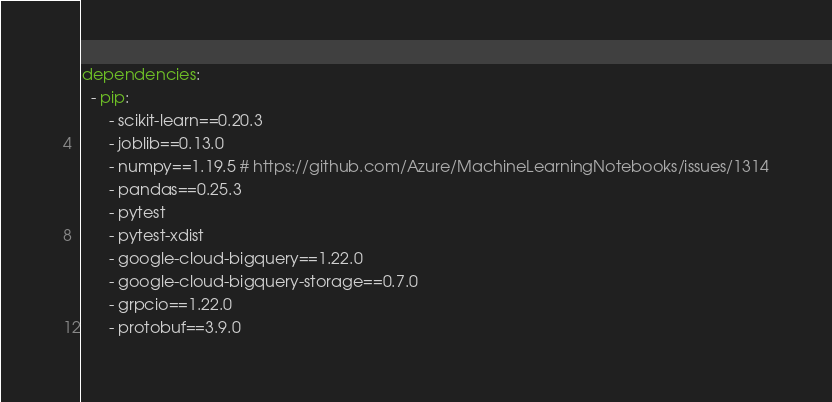<code> <loc_0><loc_0><loc_500><loc_500><_YAML_>dependencies:
  - pip:
      - scikit-learn==0.20.3
      - joblib==0.13.0
      - numpy==1.19.5 # https://github.com/Azure/MachineLearningNotebooks/issues/1314
      - pandas==0.25.3
      - pytest
      - pytest-xdist
      - google-cloud-bigquery==1.22.0
      - google-cloud-bigquery-storage==0.7.0
      - grpcio==1.22.0
      - protobuf==3.9.0
</code> 